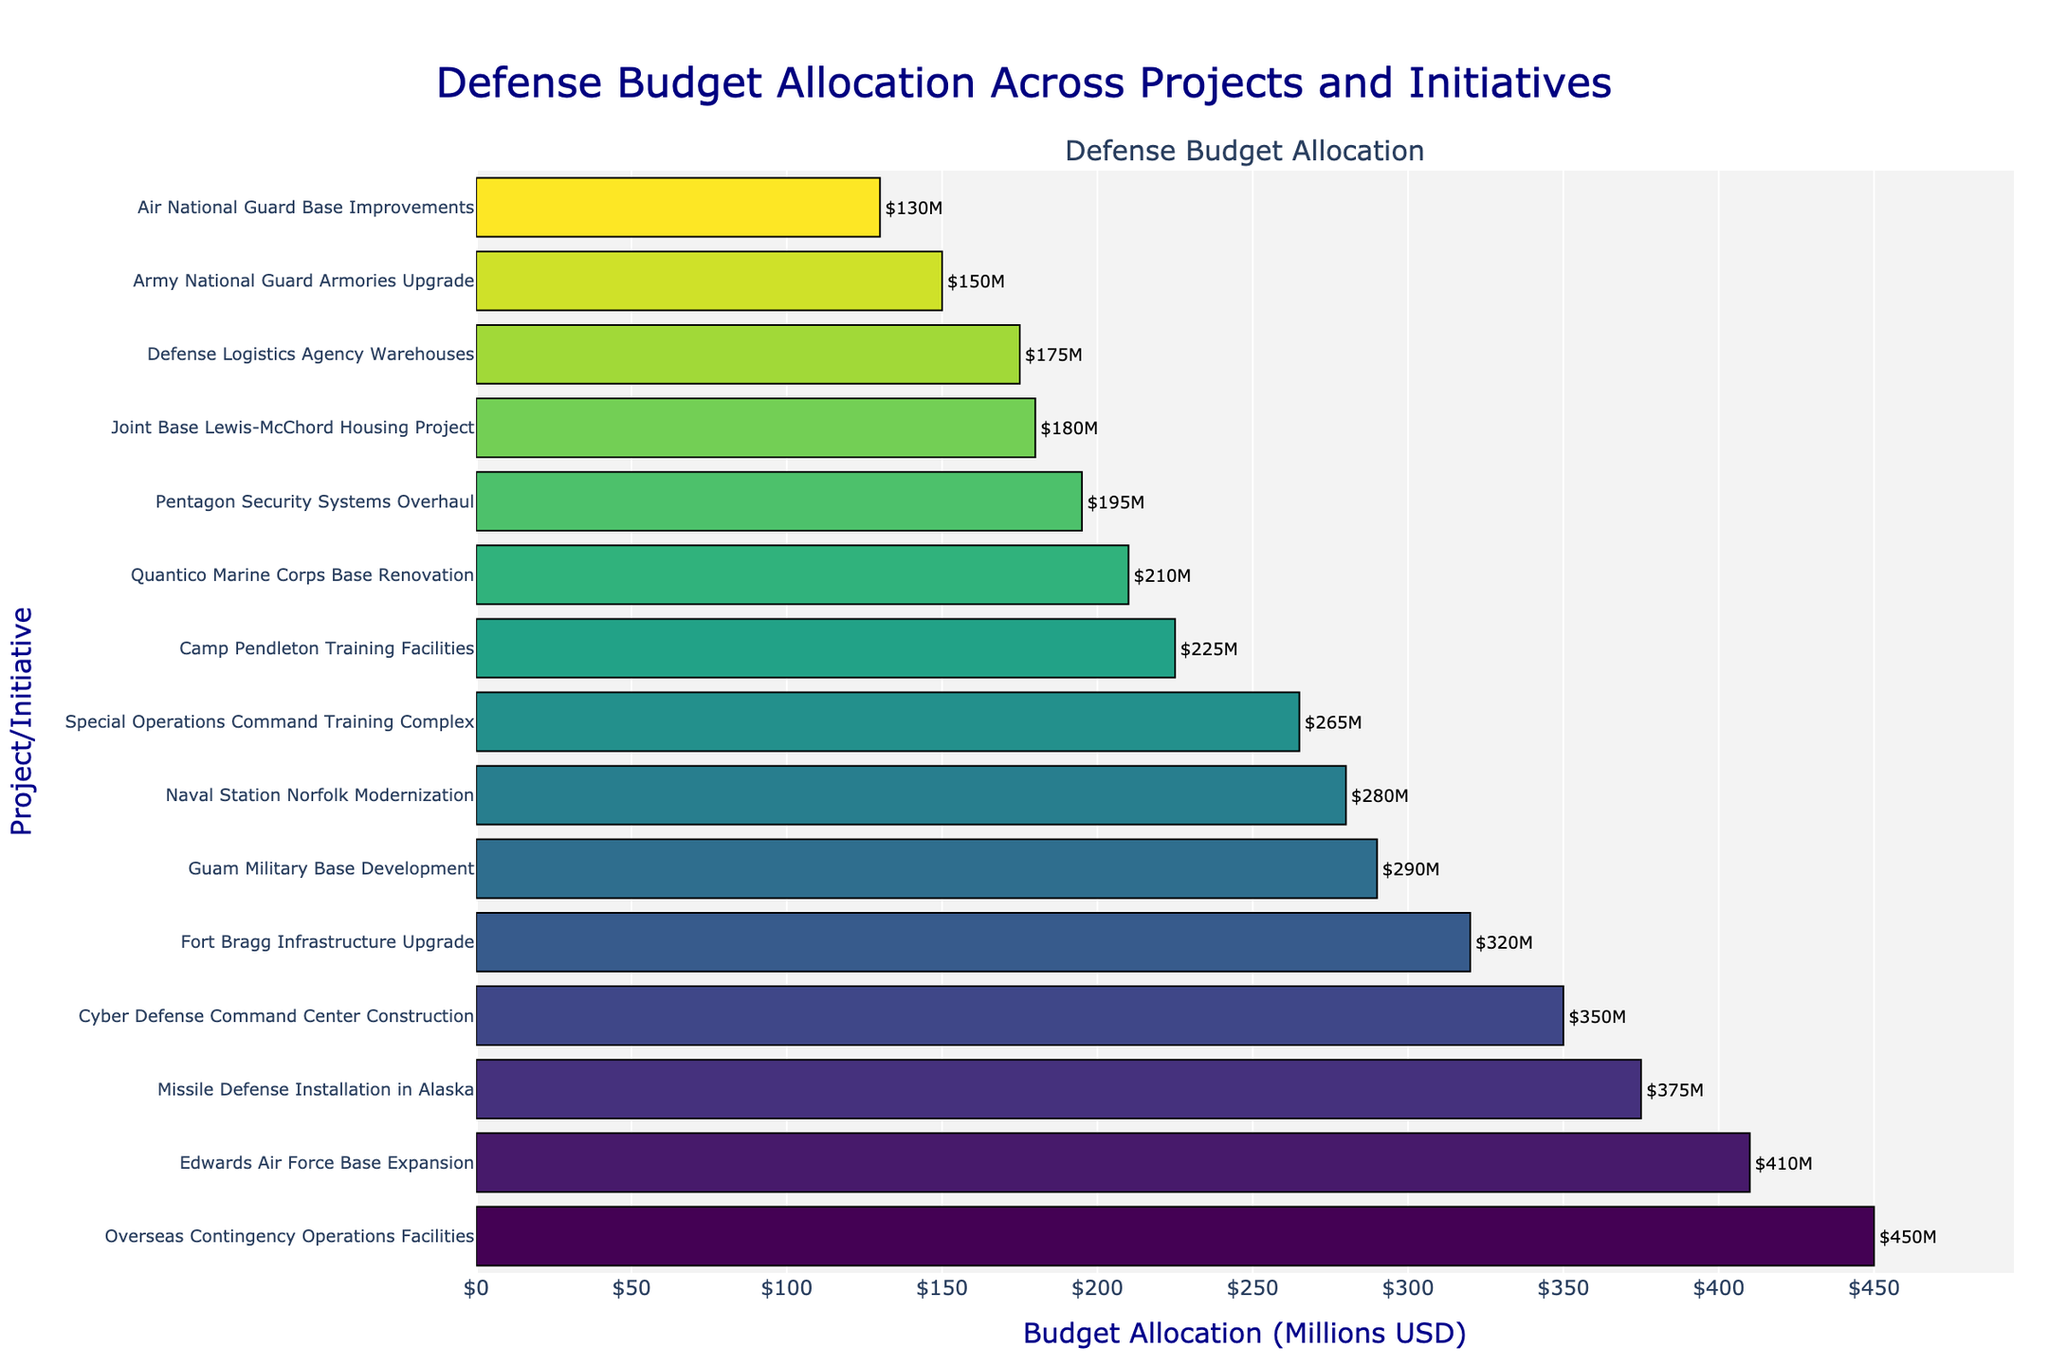Which project received the highest budget allocation? Look at the bar chart and identify the project with the longest bar. The top project listed at the start of the y-axis is "Overseas Contingency Operations Facilities" with a budget allocation of $450 million.
Answer: Overseas Contingency Operations Facilities What is the total budget allocation for Edwards Air Force Base Expansion and Missile Defense Installation in Alaska? Sum the budget allocations for the specified projects. Edwards Air Force Base Expansion has $410 million and Missile Defense Installation in Alaska has $375 million. $410M + $375M = $785M.
Answer: $785 million Which project/initiative has a higher budget allocation: Pentagon Security Systems Overhaul or Camp Pendleton Training Facilities? Compare the bar lengths for the two projects. Pentagon Security Systems Overhaul has a budget of $195 million whereas Camp Pendleton Training Facilities has $225 million.
Answer: Camp Pendleton Training Facilities How many projects/initiatives have a budget allocation less than $200 million? Count the bars with budget allocations less than $200 million by checking each project's budget allocation. The projects are Joint Base Lewis-McChord Housing Project, Army National Guard Armories Upgrade, and Air National Guard Base Improvements.
Answer: 3 What is the median budget allocation across all projects? List all budget allocations in ascending order and find the middle value. The values are 130, 150, 175, 180, 195, 210, 225, 265, 280, 290, 320, 350, 375, 410, and 450. The middle value is 265 (Special Operations Command Training Complex).
Answer: $265 million Which project has the shortest bar in the chart, and what is its budget allocation? Identify the shortest bar. The project with the shortest bar is Air National Guard Base Improvements with a budget allocation of $130 million.
Answer: Air National Guard Base Improvements, $130 million Compare the budget allocation for Defense Logistics Agency Warehouses and Naval Station Norfolk Modernization. Which one has a higher allocation and by how much? Defense Logistics Agency Warehouses has a budget of $175 million and Naval Station Norfolk Modernization has $280 million. Subtract the budget of Defense Logistics Agency Warehouses from Naval Station Norfolk Modernization: $280M - $175M = $105M.
Answer: Naval Station Norfolk Modernization, $105 million What is the average budget allocation across all projects? Sum all the budget allocations and divide by the number of projects. Total sum = 450 + 410 + 375 + 350 + 320 + 290 + 280 + 265 + 225 + 210 + 195 + 180 + 175 + 150 + 130 = 4405 million. Number of projects = 15. Average = 4405 / 15 = 293.67 million.
Answer: $293.67 million How does the budget allocation for Cyber Defense Command Center Construction compare in length and color to the Guam Military Base Development? Observe the length and color of the bars. The Cyber Defense Command Center Construction ($350M) bar is longer and has a somewhat darker shade compared to the Guam Military Base Development ($290M) bar, which is shorter and has a slightly lighter color.
Answer: Cyber Defense Command Center Construction has a longer bar and a darker shade 